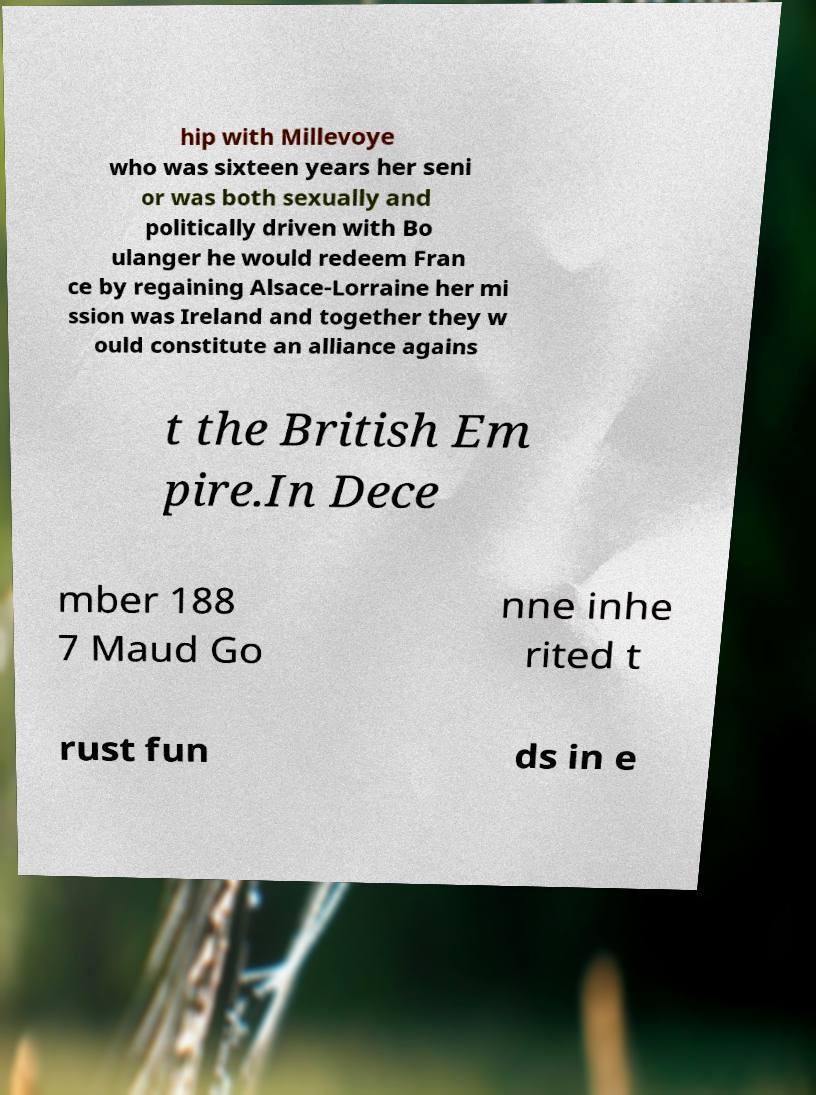Can you accurately transcribe the text from the provided image for me? hip with Millevoye who was sixteen years her seni or was both sexually and politically driven with Bo ulanger he would redeem Fran ce by regaining Alsace-Lorraine her mi ssion was Ireland and together they w ould constitute an alliance agains t the British Em pire.In Dece mber 188 7 Maud Go nne inhe rited t rust fun ds in e 